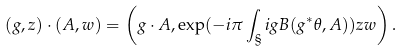<formula> <loc_0><loc_0><loc_500><loc_500>( g , z ) \cdot ( A , w ) = \left ( g \cdot A , \exp ( - i \pi \int _ { \S } i g B ( g ^ { * } \theta , A ) ) z w \right ) .</formula> 